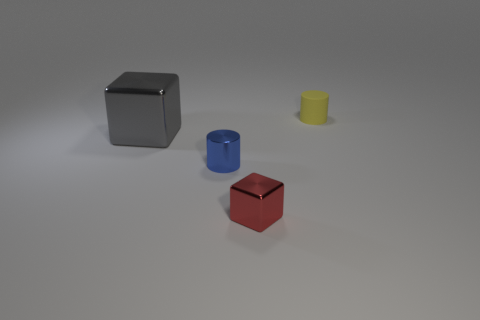What material is the small red thing?
Your answer should be very brief. Metal. Is the material of the tiny blue thing the same as the cylinder right of the red thing?
Your answer should be compact. No. Is there anything else that has the same color as the big metallic object?
Your answer should be very brief. No. Is there a red metallic object that is on the right side of the thing in front of the tiny cylinder to the left of the rubber thing?
Your answer should be compact. No. The large thing has what color?
Offer a terse response. Gray. Are there any yellow rubber objects behind the matte thing?
Offer a very short reply. No. There is a tiny yellow thing; does it have the same shape as the metal object behind the blue metallic cylinder?
Provide a succinct answer. No. What number of other things are made of the same material as the big gray object?
Offer a very short reply. 2. The metal cube behind the small cylinder that is in front of the cylinder to the right of the red object is what color?
Provide a succinct answer. Gray. There is a tiny thing on the left side of the block on the right side of the small blue object; what is its shape?
Ensure brevity in your answer.  Cylinder. 